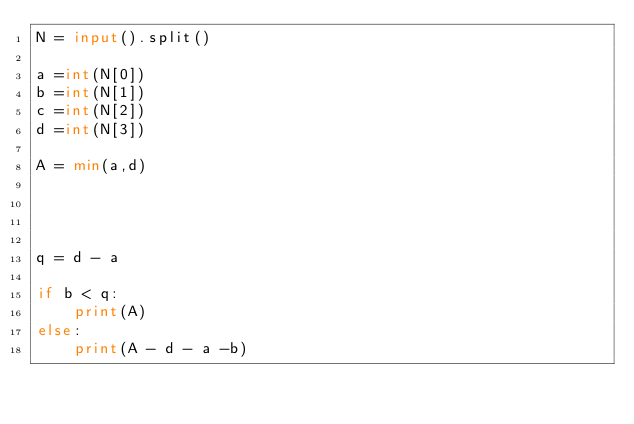Convert code to text. <code><loc_0><loc_0><loc_500><loc_500><_Python_>N = input().split()

a =int(N[0])
b =int(N[1])
c =int(N[2])
d =int(N[3])

A = min(a,d)


    
    
q = d - a

if b < q:
    print(A)
else:
    print(A - d - a -b)</code> 